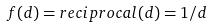Convert formula to latex. <formula><loc_0><loc_0><loc_500><loc_500>f ( d ) = r e c i p r o c a l ( d ) = 1 / d</formula> 